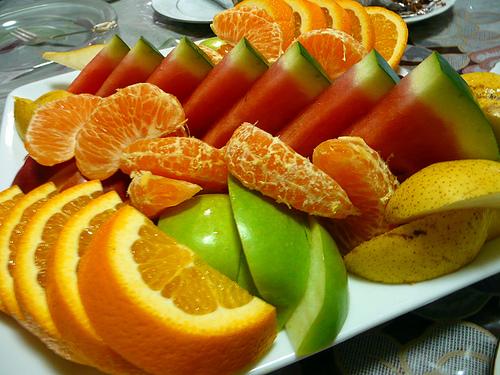What is the green and red fruit?
Concise answer only. Watermelon. Is the orange sliced?
Write a very short answer. Yes. How many different fruits are on the plate?
Be succinct. 4. 